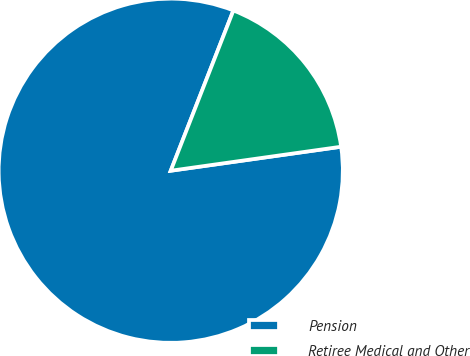Convert chart. <chart><loc_0><loc_0><loc_500><loc_500><pie_chart><fcel>Pension<fcel>Retiree Medical and Other<nl><fcel>83.16%<fcel>16.84%<nl></chart> 